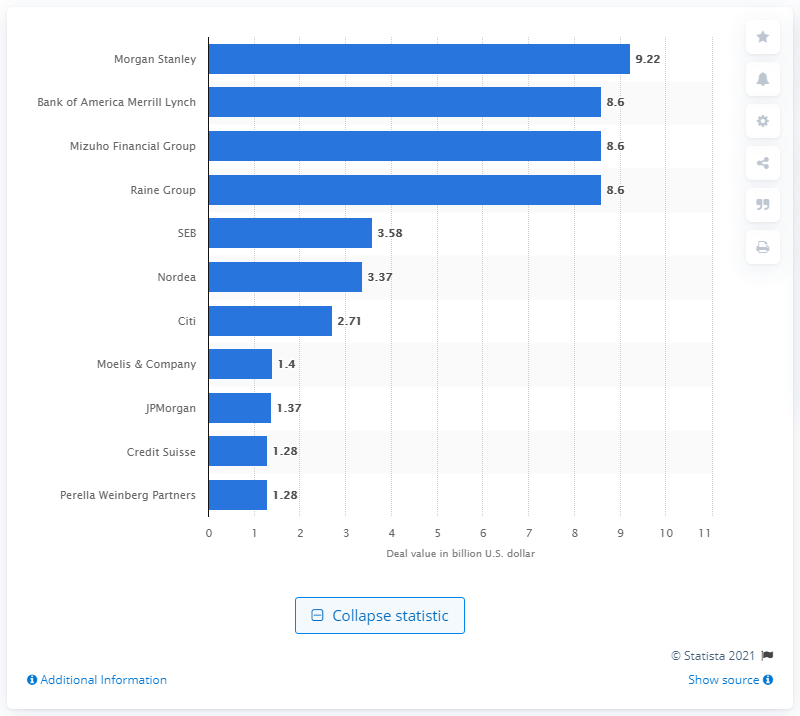Point out several critical features in this image. In 2016, Morgan Stanley was the top financial advisory firm for mergers and acquisitions in Finland. In 2016, the deal value of Morgan Stanley was approximately 9.22. 